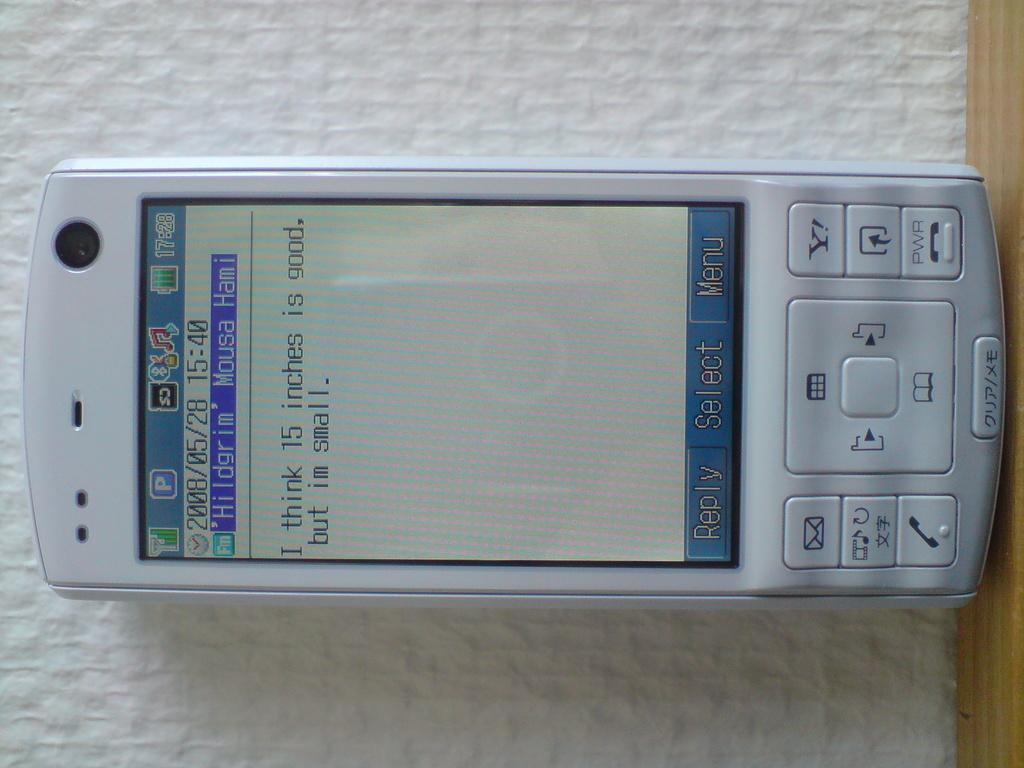<image>
Write a terse but informative summary of the picture. white cellphone displaying text message I think 15 inches is good, but im small 